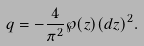<formula> <loc_0><loc_0><loc_500><loc_500>q = - \frac { 4 } { \pi ^ { 2 } } \wp ( z ) ( d z ) ^ { 2 } .</formula> 